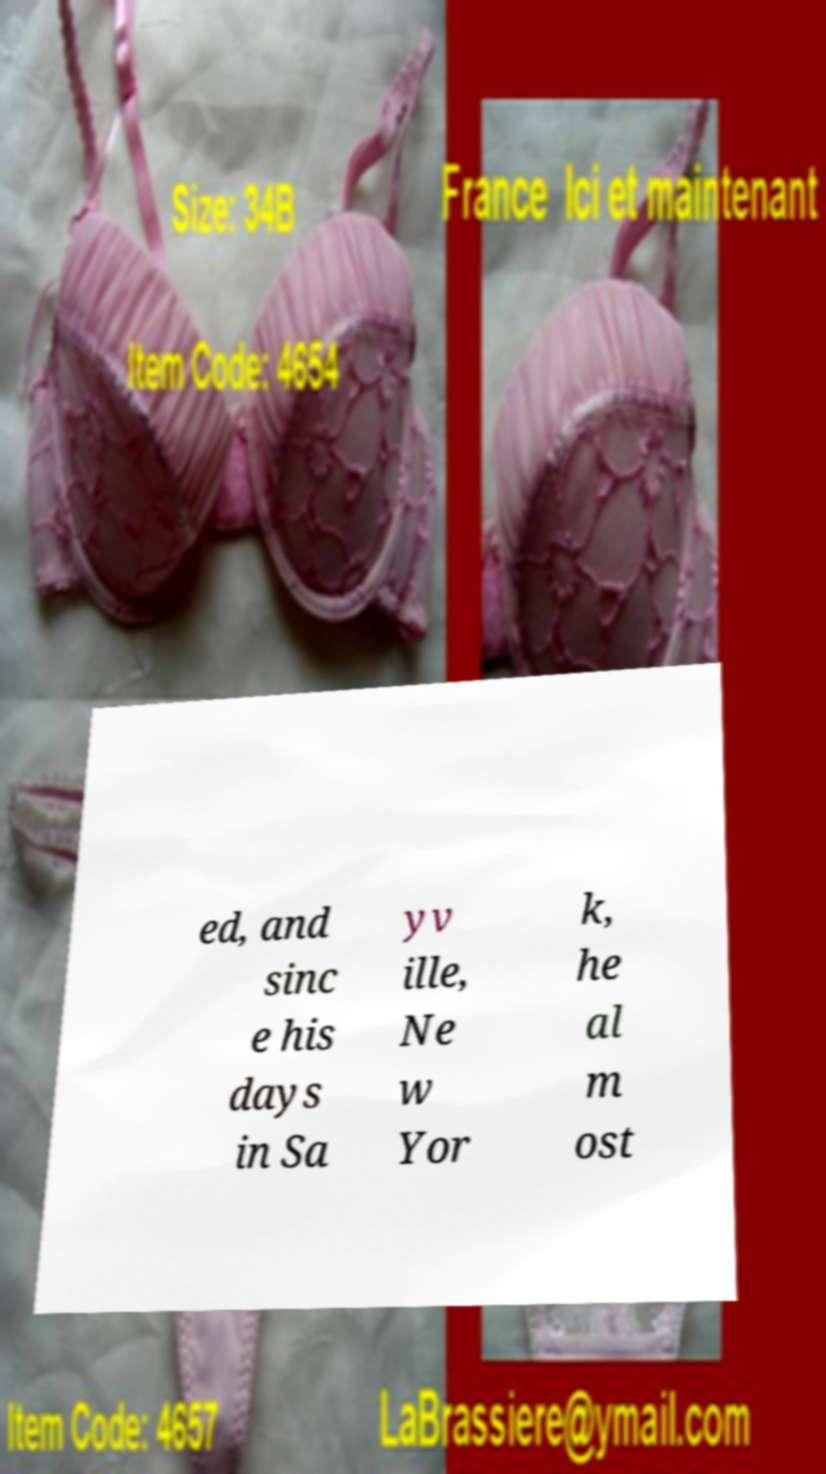Can you read and provide the text displayed in the image?This photo seems to have some interesting text. Can you extract and type it out for me? ed, and sinc e his days in Sa yv ille, Ne w Yor k, he al m ost 